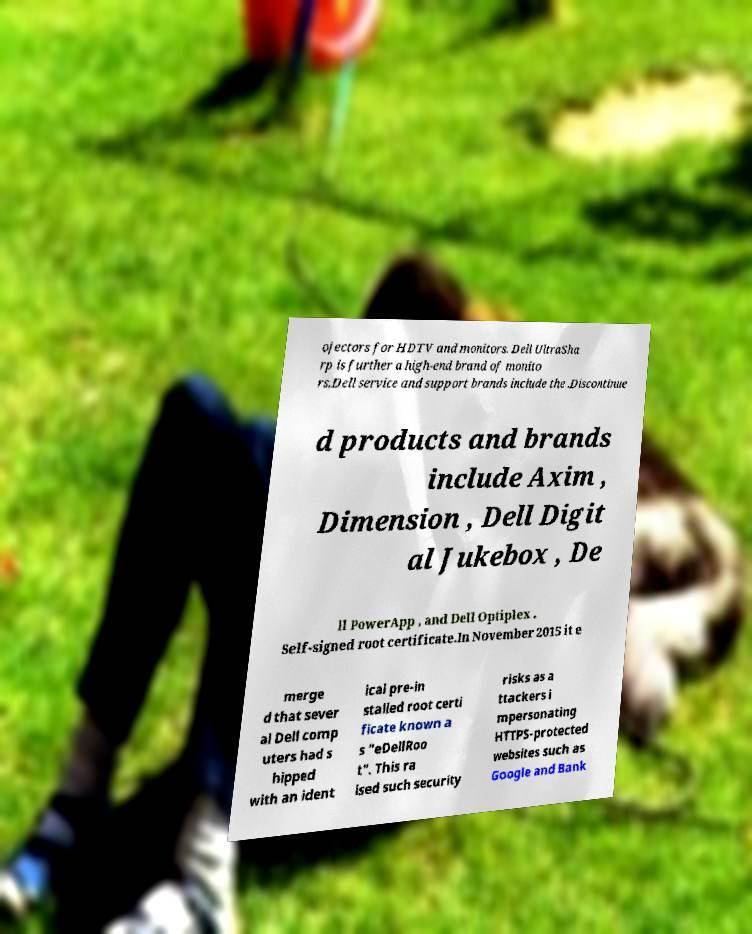Could you assist in decoding the text presented in this image and type it out clearly? ojectors for HDTV and monitors. Dell UltraSha rp is further a high-end brand of monito rs.Dell service and support brands include the .Discontinue d products and brands include Axim , Dimension , Dell Digit al Jukebox , De ll PowerApp , and Dell Optiplex . Self-signed root certificate.In November 2015 it e merge d that sever al Dell comp uters had s hipped with an ident ical pre-in stalled root certi ficate known a s "eDellRoo t". This ra ised such security risks as a ttackers i mpersonating HTTPS-protected websites such as Google and Bank 